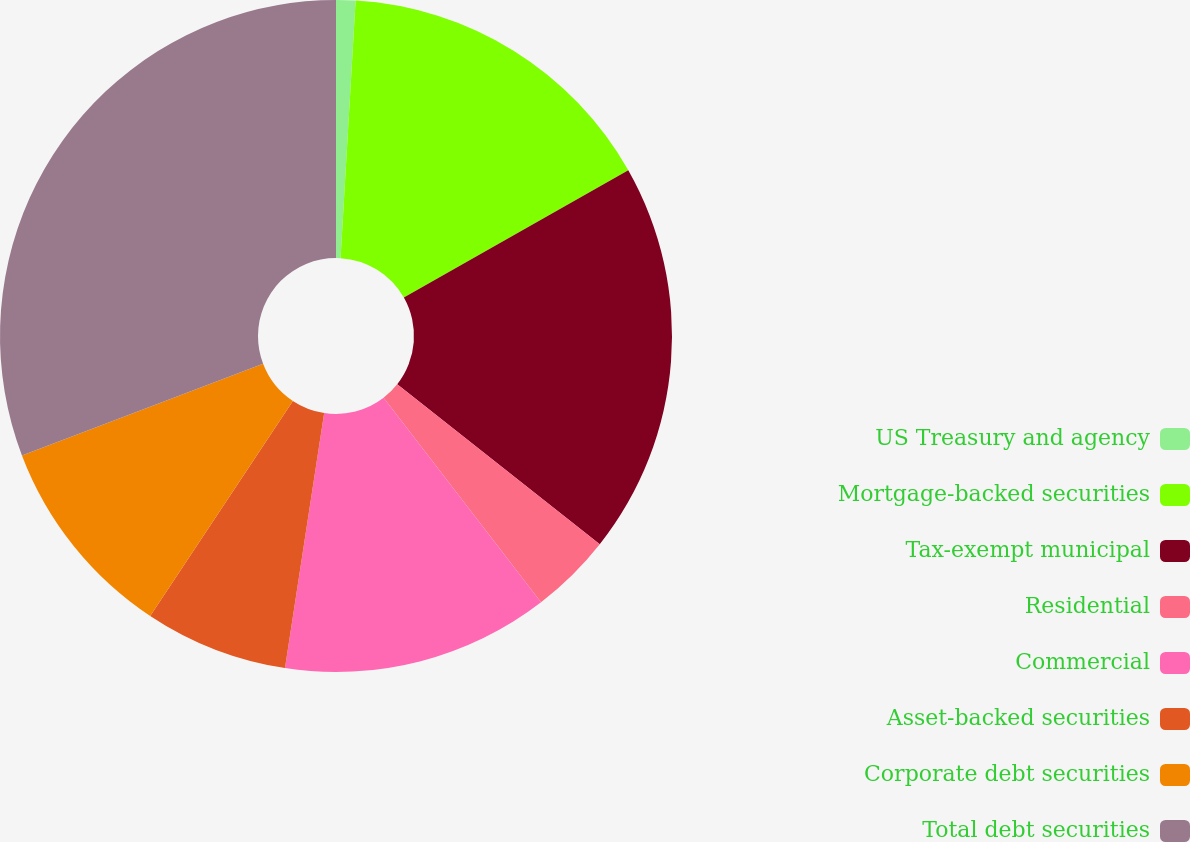Convert chart. <chart><loc_0><loc_0><loc_500><loc_500><pie_chart><fcel>US Treasury and agency<fcel>Mortgage-backed securities<fcel>Tax-exempt municipal<fcel>Residential<fcel>Commercial<fcel>Asset-backed securities<fcel>Corporate debt securities<fcel>Total debt securities<nl><fcel>0.93%<fcel>15.86%<fcel>18.84%<fcel>3.92%<fcel>12.87%<fcel>6.9%<fcel>9.89%<fcel>30.78%<nl></chart> 